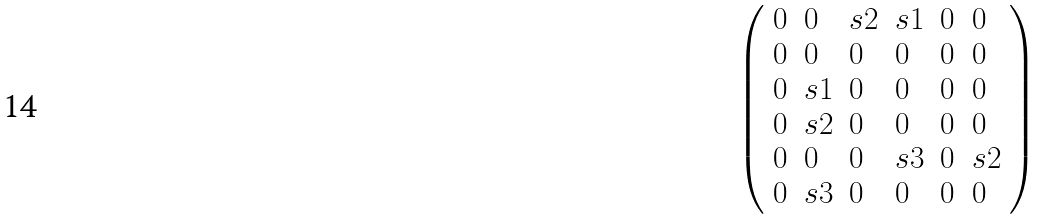<formula> <loc_0><loc_0><loc_500><loc_500>\left ( \begin{array} { l l l l l l } { 0 } & { 0 } & { s 2 } & { s 1 } & { 0 } & { 0 } \\ { 0 } & { 0 } & { 0 } & { 0 } & { 0 } & { 0 } \\ { 0 } & { s 1 } & { 0 } & { 0 } & { 0 } & { 0 } \\ { 0 } & { s 2 } & { 0 } & { 0 } & { 0 } & { 0 } \\ { 0 } & { 0 } & { 0 } & { s 3 } & { 0 } & { s 2 } \\ { 0 } & { s 3 } & { 0 } & { 0 } & { 0 } & { 0 } \end{array} \right )</formula> 